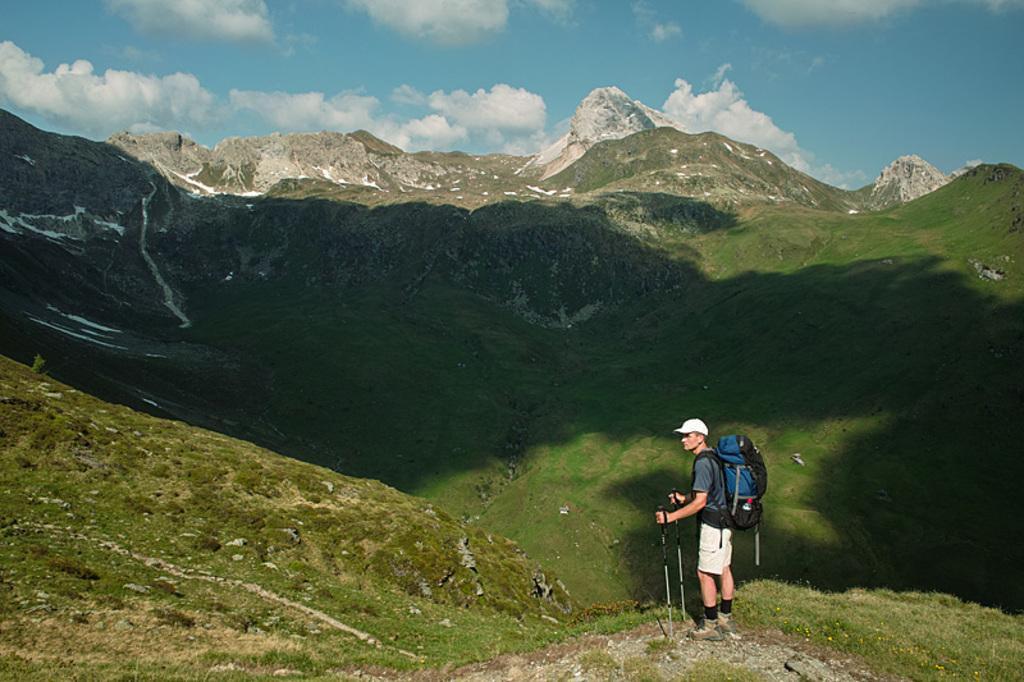How would you summarize this image in a sentence or two? In this image I see a man who is holding the sticks and wearing a bag and is standing on the grass. In the background I see the mountains and the sky. 